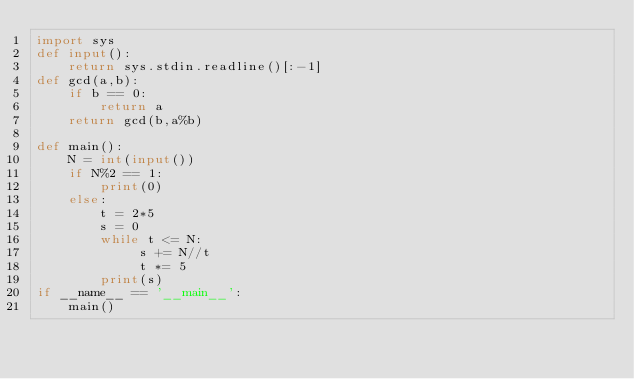Convert code to text. <code><loc_0><loc_0><loc_500><loc_500><_Python_>import sys
def input():
    return sys.stdin.readline()[:-1]
def gcd(a,b):
    if b == 0:
        return a
    return gcd(b,a%b)

def main():
    N = int(input())
    if N%2 == 1:
        print(0)
    else:
        t = 2*5
        s = 0
        while t <= N:
             s += N//t
             t *= 5
        print(s)
if __name__ == '__main__':
    main()
</code> 